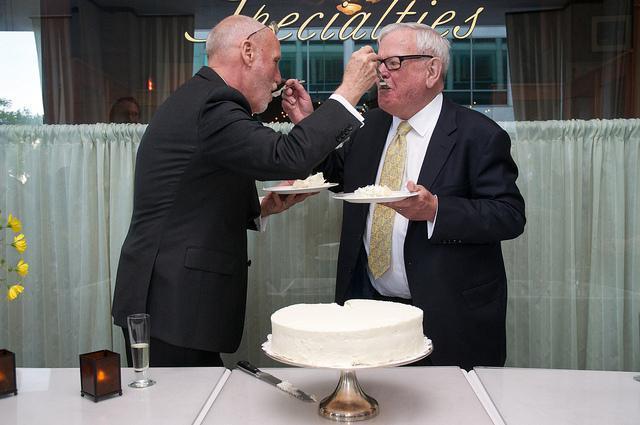How many slices of cake has been cut?
Give a very brief answer. 2. How many people are there?
Give a very brief answer. 2. How many of the sheep are black and white?
Give a very brief answer. 0. 